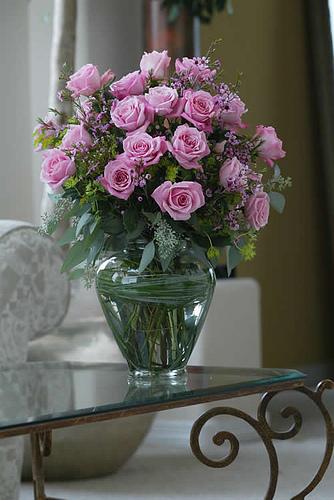What color are the flower stems?
Keep it brief. Green. What kind of flowers are these?
Quick response, please. Roses. What color is the rose?
Be succinct. Pink. What kind of reflection do you see on the floor?
Short answer required. None. In what setting was this photo taken?
Write a very short answer. Living room. What is on the table?
Concise answer only. Flowers. How many blooms are in the center vase?
Short answer required. 14. Is this a pretty arrangement?
Quick response, please. Yes. Are these spring flowers?
Quick response, please. Yes. Are the flowers alive?
Quick response, please. Yes. Do you see a strawberry fruit?
Concise answer only. No. What color is the vase?
Quick response, please. Clear. What is the pink object?
Answer briefly. Flowers. How many onions?
Quick response, please. 0. Which vase has the most water in it?
Quick response, please. Clear. What color are the flowers?
Answer briefly. Pink. Are the flowers all the same color?
Keep it brief. Yes. Does the table seem to be floating or are it's legs clearly evident?
Quick response, please. Evident. What is draped around the vase?
Keep it brief. Flowers. Are there any carnations in the vase?
Answer briefly. No. Is the vase elaborate?
Be succinct. No. What color are the walls?
Answer briefly. Tan. Does this come when you order flowers?
Give a very brief answer. Yes. Are these artificial flowers?
Keep it brief. No. 